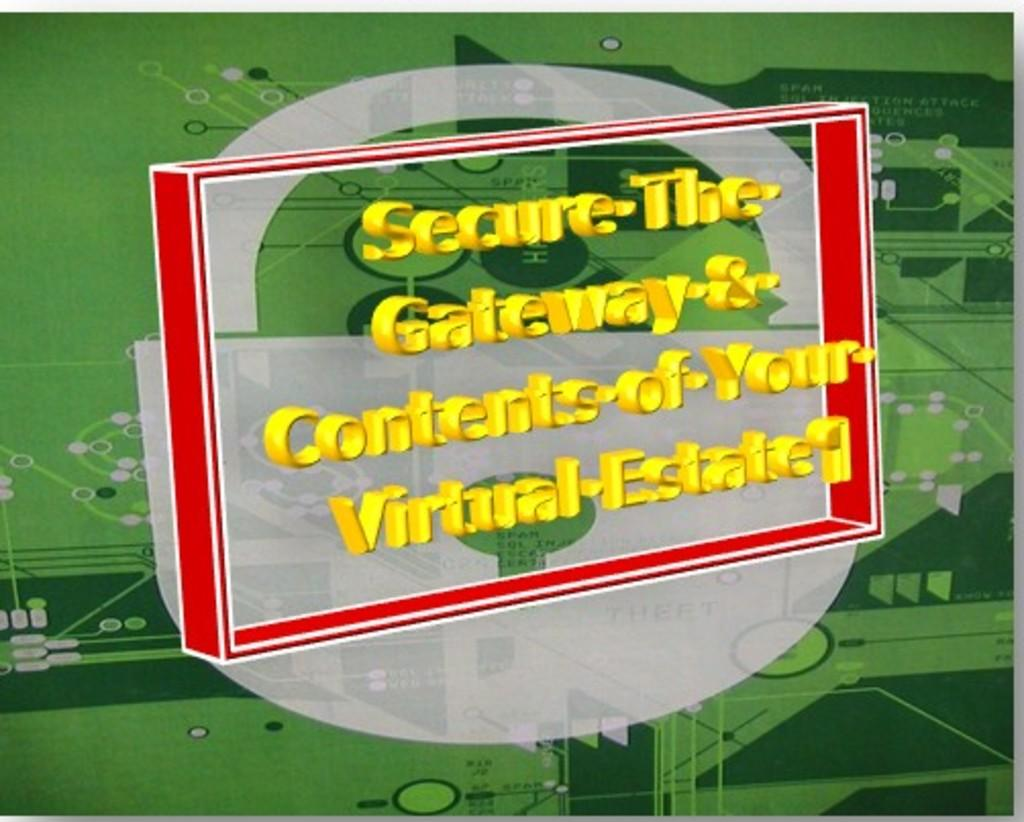What is the main object in the image? There is a digital screen in the image. What is happening on the digital screen? Content is rolling on the digital screen. What is the porter doing in the image? There is no porter present in the image. How many points are visible on the digital screen? The image does not specify the number of points on the digital screen, as it only mentions that content is rolling on the screen. 